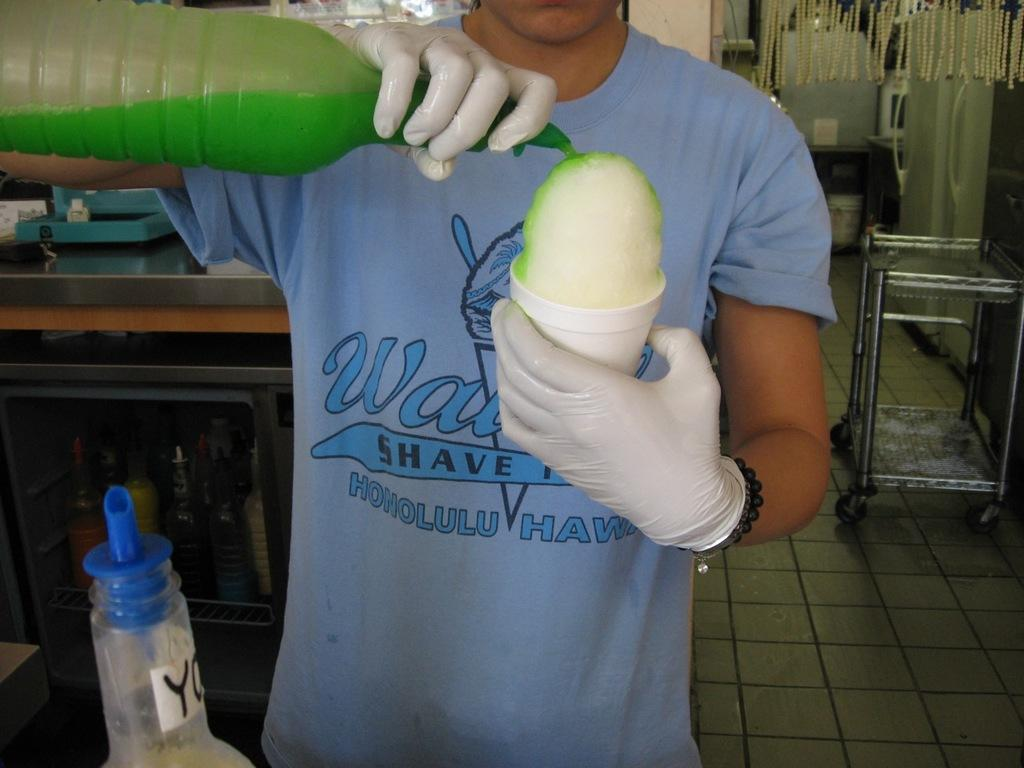What is the main subject of the image? There is a person in the image. What is the person wearing? The person is wearing a blue shirt. What is the person doing in the image? The person is mixing a color to an object in their hands. How does the person grade the form in the image? There is no form or grading activity present in the image; the person is mixing a color to an object in their hands. 